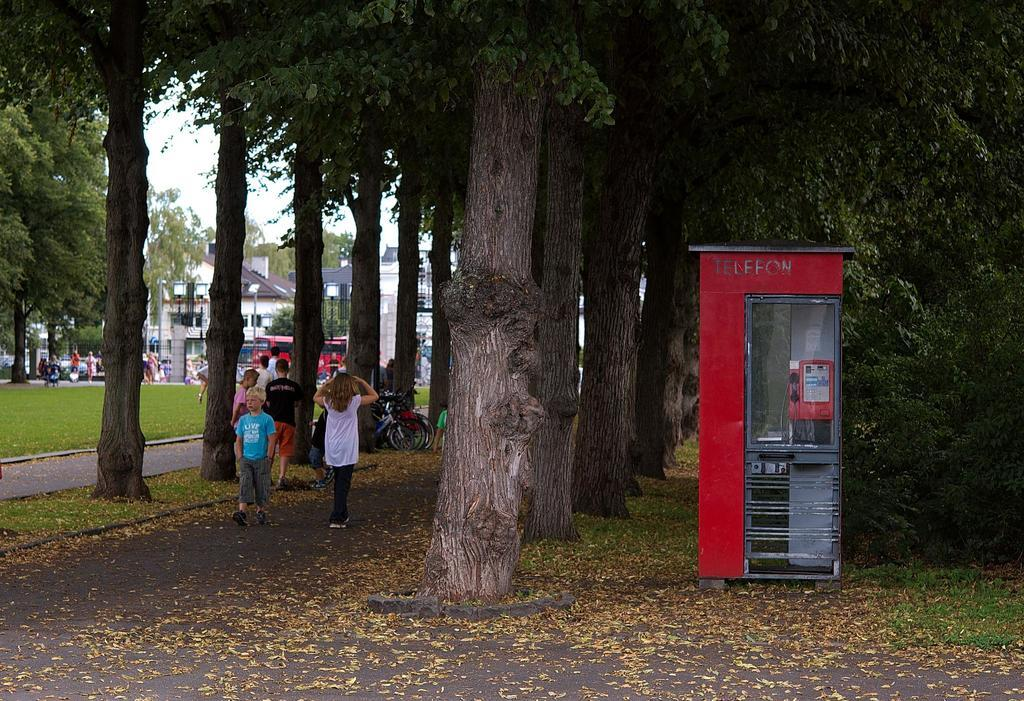How many people can be seen in the image? There are people in the image, but the exact number is not specified. What type of surface is visible under the people's feet? The ground is visible in the image, and grass is present on the ground. What other natural elements can be seen in the image? Trees are visible in the image, and dry leaves are present on the ground. What type of structure is present in the image? There is a booth in the image. What are the poles used for in the image? Poles are present in the image, and lights are attached to the poles. What type of buildings can be seen in the image? Buildings are visible in the image. What part of the sky is visible in the image? The sky is visible in the image. How many tin beds are visible in the image? There is no mention of tin beds in the image, so it is not possible to answer this question. 